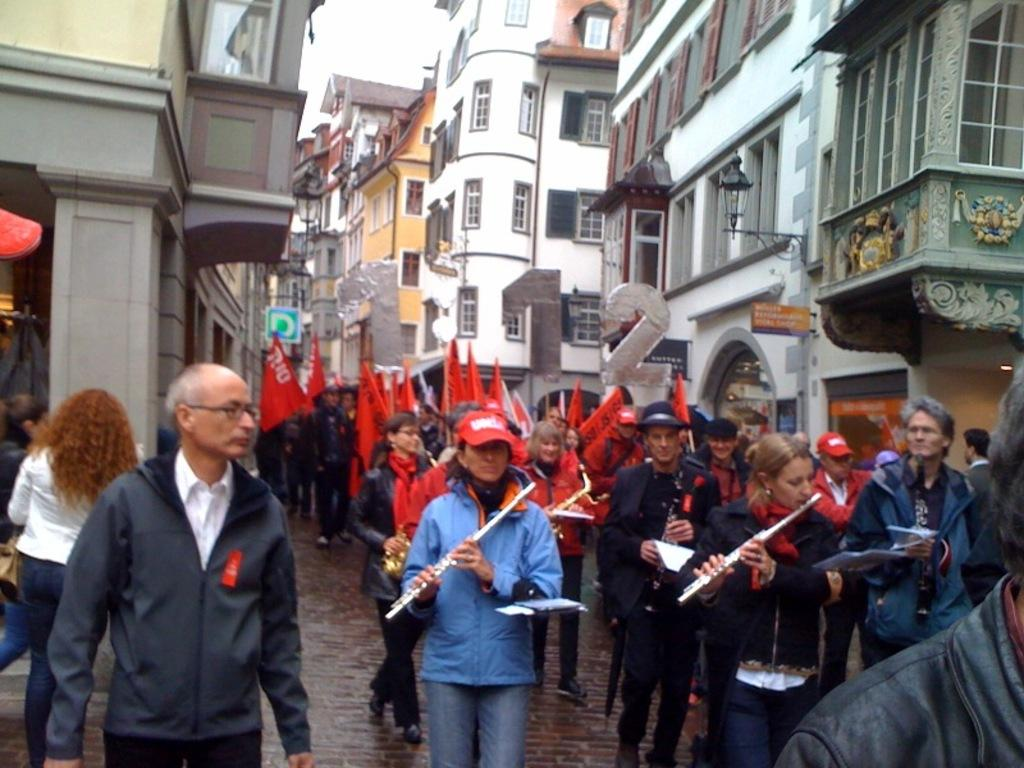What are the people in the image doing? The people in the image are standing in series. What are the people holding in their hands? The people are holding flags in their hands. What can be seen in the background of the image? There are buildings visible at the top side of the image. What type of blade is being used by the people in the image? There is no blade present in the image; the people are holding flags. 